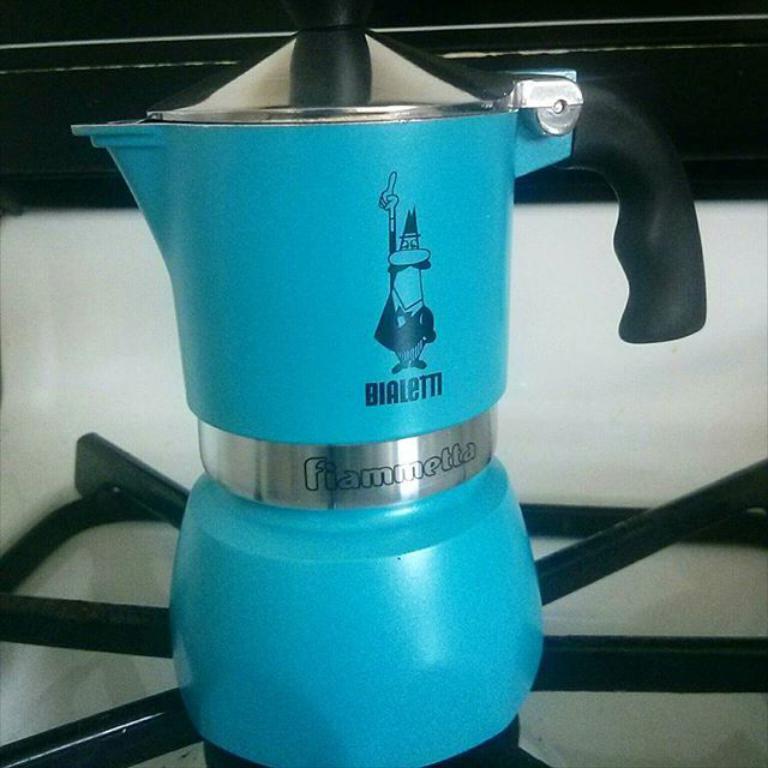What is written on the silver part of the object?
Give a very brief answer. Fiammetta. 